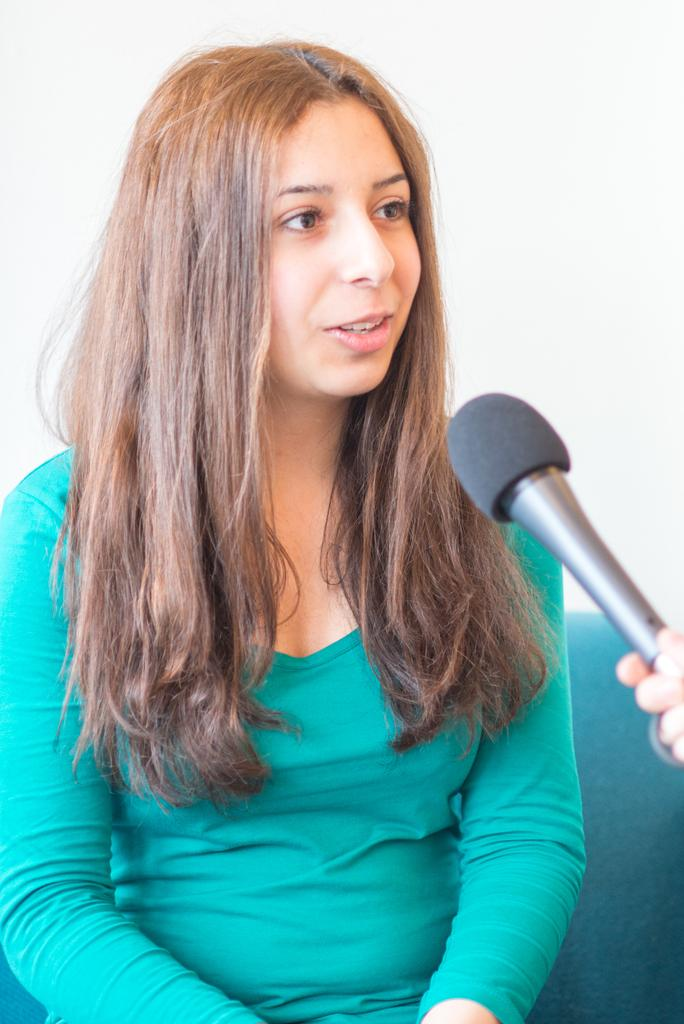Who is the main subject in the image? There is a woman in the image. What is the woman doing in the image? The woman is seated in the image. What object is in front of the woman? There is a microphone in front of the woman. Can you see a cat playing with an ear of corn in the image? There is no cat or ear of corn present in the image. What type of eggnog is being served in the image? There is no eggnog present in the image. 